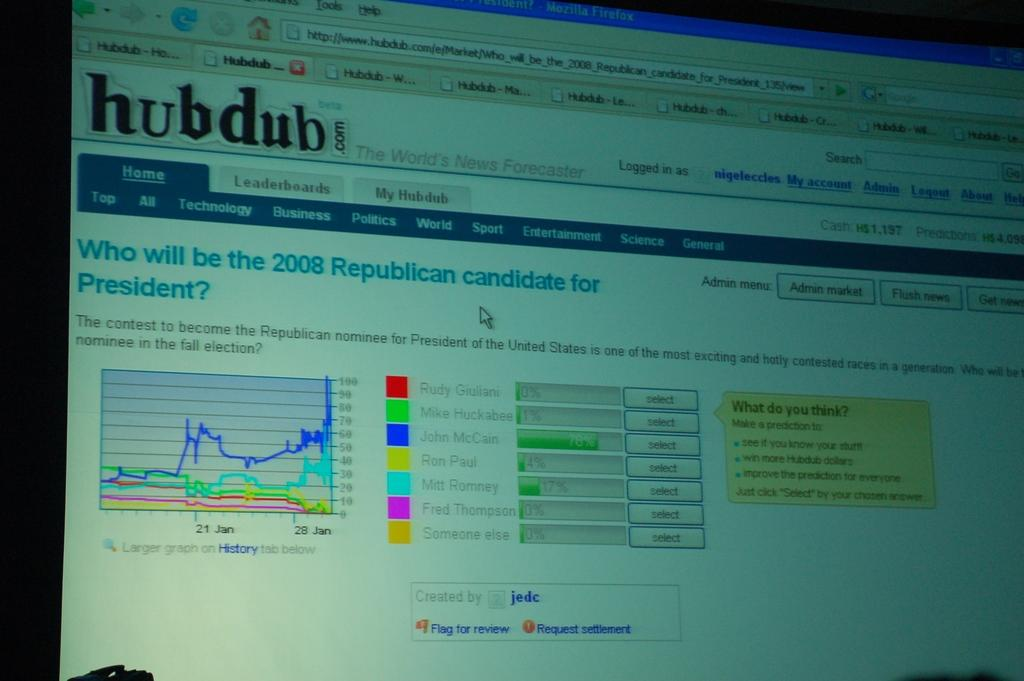<image>
Present a compact description of the photo's key features. A screen that shows a website called hubdub. 